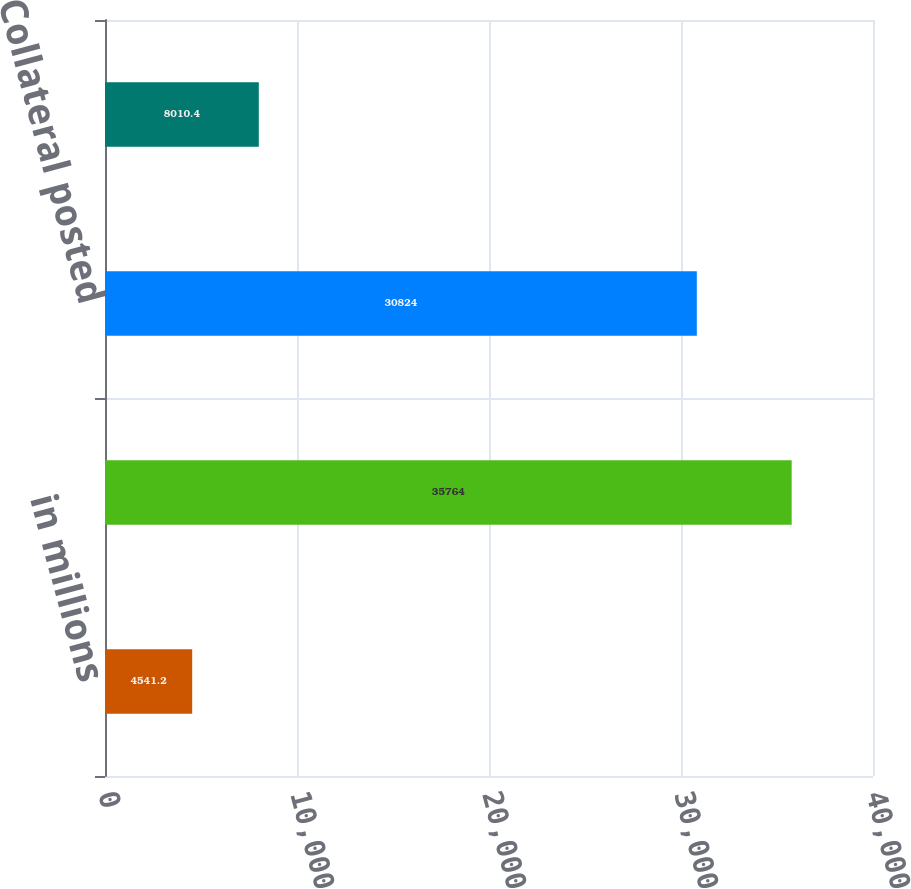Convert chart. <chart><loc_0><loc_0><loc_500><loc_500><bar_chart><fcel>in millions<fcel>Net derivative liabilities<fcel>Collateral posted<fcel>Additional collateral or<nl><fcel>4541.2<fcel>35764<fcel>30824<fcel>8010.4<nl></chart> 